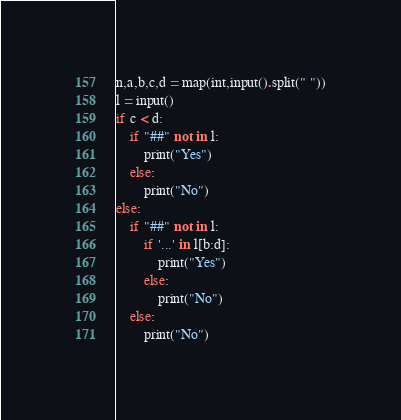<code> <loc_0><loc_0><loc_500><loc_500><_Python_>n,a,b,c,d = map(int,input().split(" "))
l = input()
if c < d:
    if "##" not in l:
        print("Yes")
    else:
        print("No")
else:
    if "##" not in l:
        if '...' in l[b:d]:
            print("Yes")
        else:
            print("No")
    else:
        print("No")</code> 